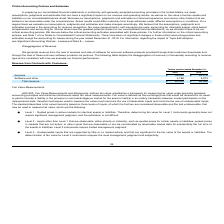From Support Com's financial document, In which years was the revenue from contracts with customers recorded for? The document shows two values: 2019 and 2018. From the document: "2019 2018 2019 2018..." Also, How does the company create revenue? from the sale of services and sale of software for end-user software products provided through direct customer downloads and through the sale of these end-user software products via partners.. The document states: "We generate revenue from the sale of services and sale of software for end-user software products provided through direct customer downloads and throu..." Also, What was the revenue from services in 2018? According to the financial document, $64,476 (in thousands). The relevant text states: "Services $ 59,545 $ 64,476..." Additionally, Which year was the software and other revenue higher? According to the financial document, 2018. The relevant text states: "2019 2018..." Also, can you calculate: What was the change in services revenue between 2018 and 2019? Based on the calculation: $59,545 - $64,476 , the result is -4931 (in thousands). This is based on the information: "Services $ 59,545 $ 64,476 Services $ 59,545 $ 64,476..." The key data points involved are: 59,545, 64,476. Also, can you calculate: What was the percentage change in total revenue between 2018 and 2019? To answer this question, I need to perform calculations using the financial data. The calculation is: ($63,333 - $69,549)/$69,549 , which equals -8.94 (percentage). This is based on the information: "Total revenue $ 63,333 $ 69,549 Total revenue $ 63,333 $ 69,549..." The key data points involved are: 63,333, 69,549. 